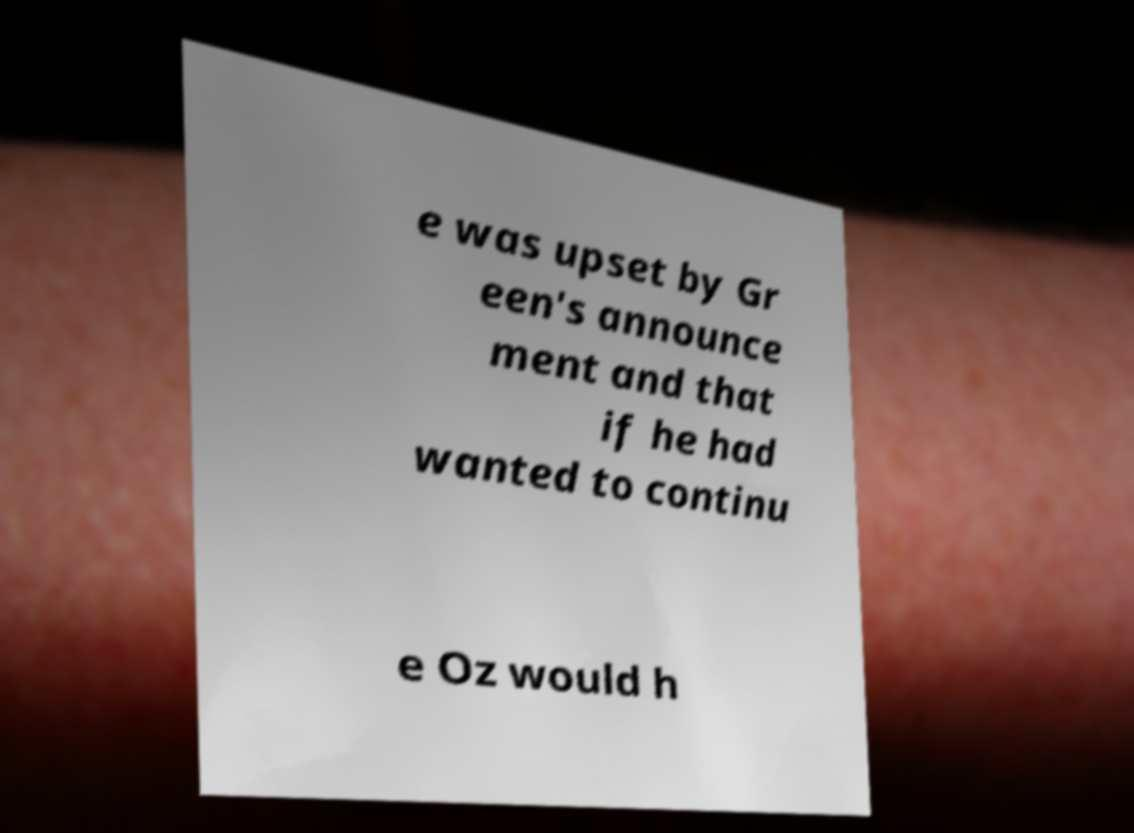What messages or text are displayed in this image? I need them in a readable, typed format. e was upset by Gr een's announce ment and that if he had wanted to continu e Oz would h 